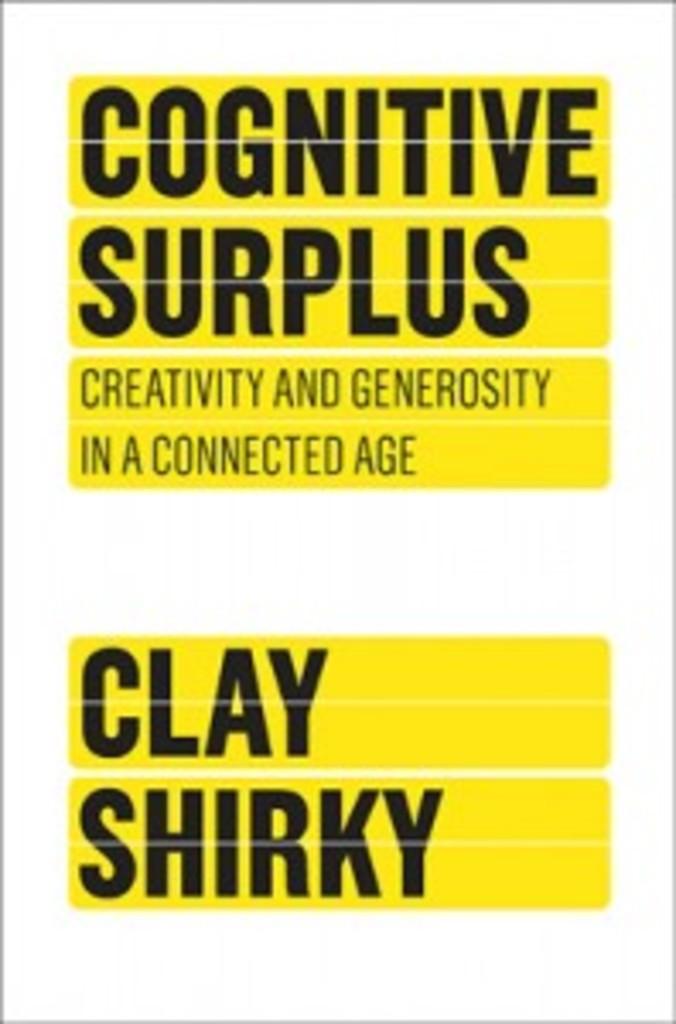What is the name on the poster?
Provide a short and direct response. Clay shirky. What has a surplus?
Provide a succinct answer. Cognitive. 